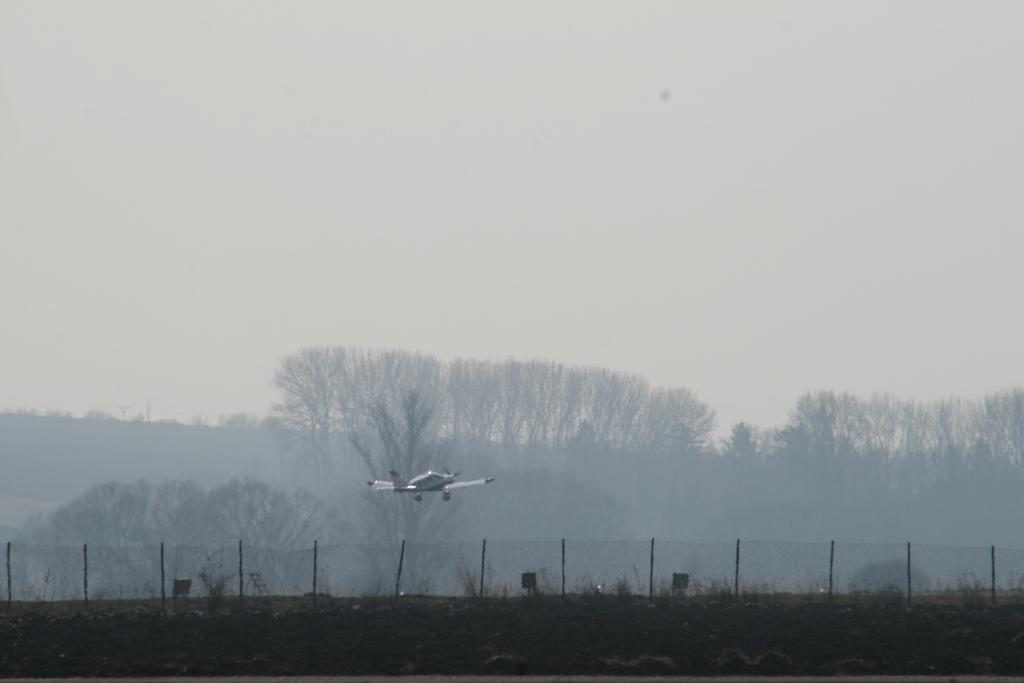What is flying in the sky in the image? There is an aircraft in the sky in the image. What type of barrier can be seen in the image? There is a metal fence in the image. What can be seen in the distance in the image? Trees are visible in the background of the image. What is present in the sky along with the aircraft? Clouds are present in the sky. What type of waves can be seen crashing against the aircraft in the image? There are no waves present in the image, as it features an aircraft in the sky and not near any body of water. 